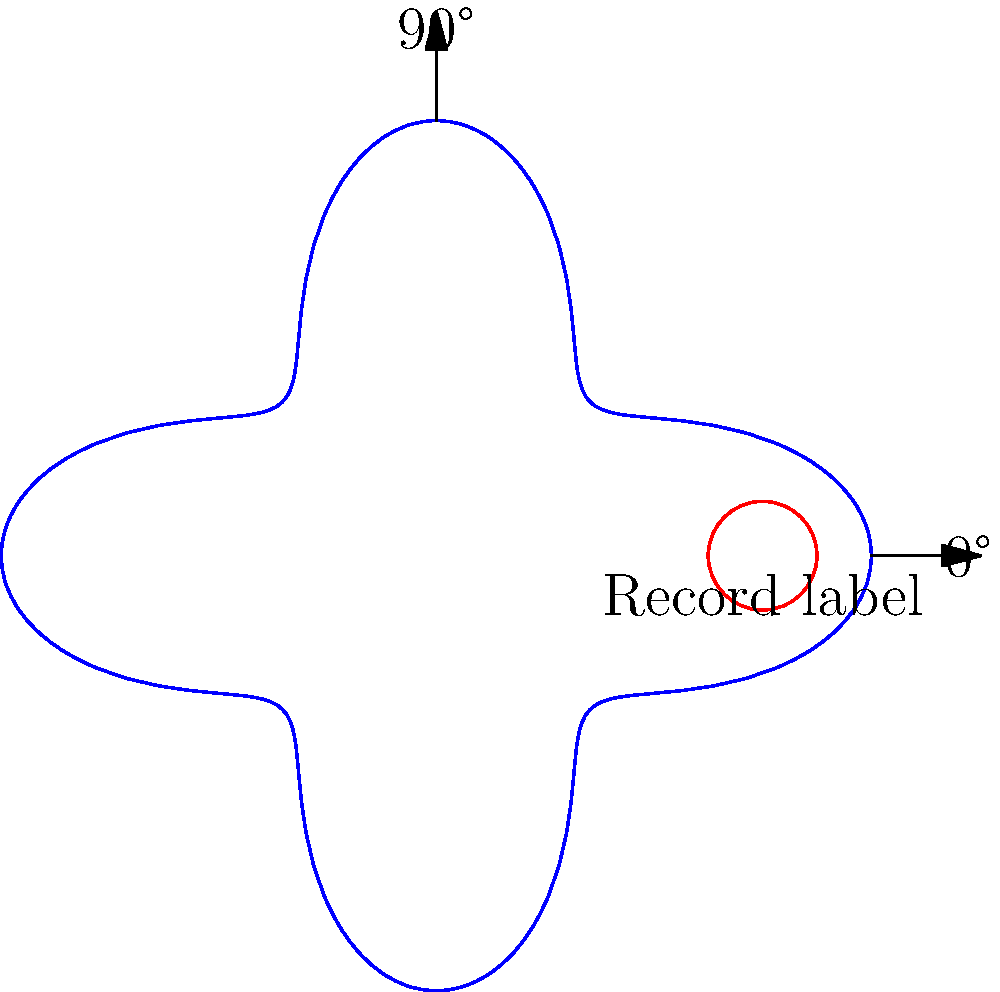A rare funk record label has a unique design that follows the polar equation $r = 3 + \cos(4\theta)$ (in cm). If the label is rotated clockwise by 45°, what will be the new polar equation describing its shape? To solve this problem, we need to understand how rotation affects polar equations:

1. The general form of rotation in polar coordinates is:
   If $r = f(\theta)$ is rotated by an angle $\alpha$, the new equation is $r = f(\theta + \alpha)$

2. In this case, our original equation is:
   $r = 3 + \cos(4\theta)$

3. We're rotating clockwise by 45°. In polar coordinates, clockwise rotation is represented by adding the angle:
   $\alpha = 45° = \frac{\pi}{4}$ radians

4. Substituting into the rotation formula:
   $r = 3 + \cos(4(\theta + \frac{\pi}{4}))$

5. Simplify inside the parentheses:
   $r = 3 + \cos(4\theta + \pi)$

6. Using the cosine angle addition formula: $\cos(A + \pi) = -\cos(A)$
   $r = 3 - \cos(4\theta)$

Therefore, the new polar equation after rotation is $r = 3 - \cos(4\theta)$.
Answer: $r = 3 - \cos(4\theta)$ 